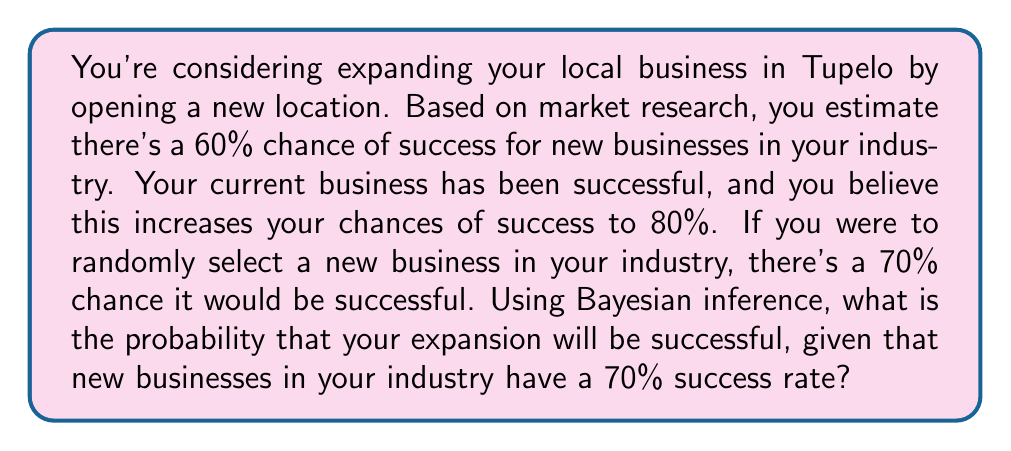Provide a solution to this math problem. Let's use Bayes' theorem to solve this problem. We'll define the following events:

A: Your business expansion is successful
B: New businesses in your industry are successful

We're given:
P(A) = 0.80 (your prior probability of success)
P(B|A) = 0.70 (probability of industry success given your success)
P(B) = 0.70 (probability of industry success in general)

We want to find P(A|B), the probability of your success given industry success.

Bayes' theorem states:

$$ P(A|B) = \frac{P(B|A) \cdot P(A)}{P(B)} $$

Step 1: Plug in the known values
$$ P(A|B) = \frac{0.70 \cdot 0.80}{0.70} $$

Step 2: Simplify
$$ P(A|B) = \frac{0.56}{0.70} $$

Step 3: Calculate the final probability
$$ P(A|B) = 0.80 $$

Therefore, the probability that your expansion will be successful, given the industry success rate, is 0.80 or 80%.
Answer: 0.80 or 80% 